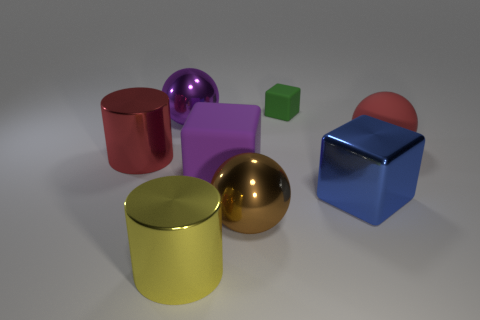Add 1 small rubber objects. How many objects exist? 9 Subtract all cylinders. How many objects are left? 6 Subtract all brown matte objects. Subtract all big red cylinders. How many objects are left? 7 Add 1 big brown balls. How many big brown balls are left? 2 Add 2 big yellow things. How many big yellow things exist? 3 Subtract 0 brown blocks. How many objects are left? 8 